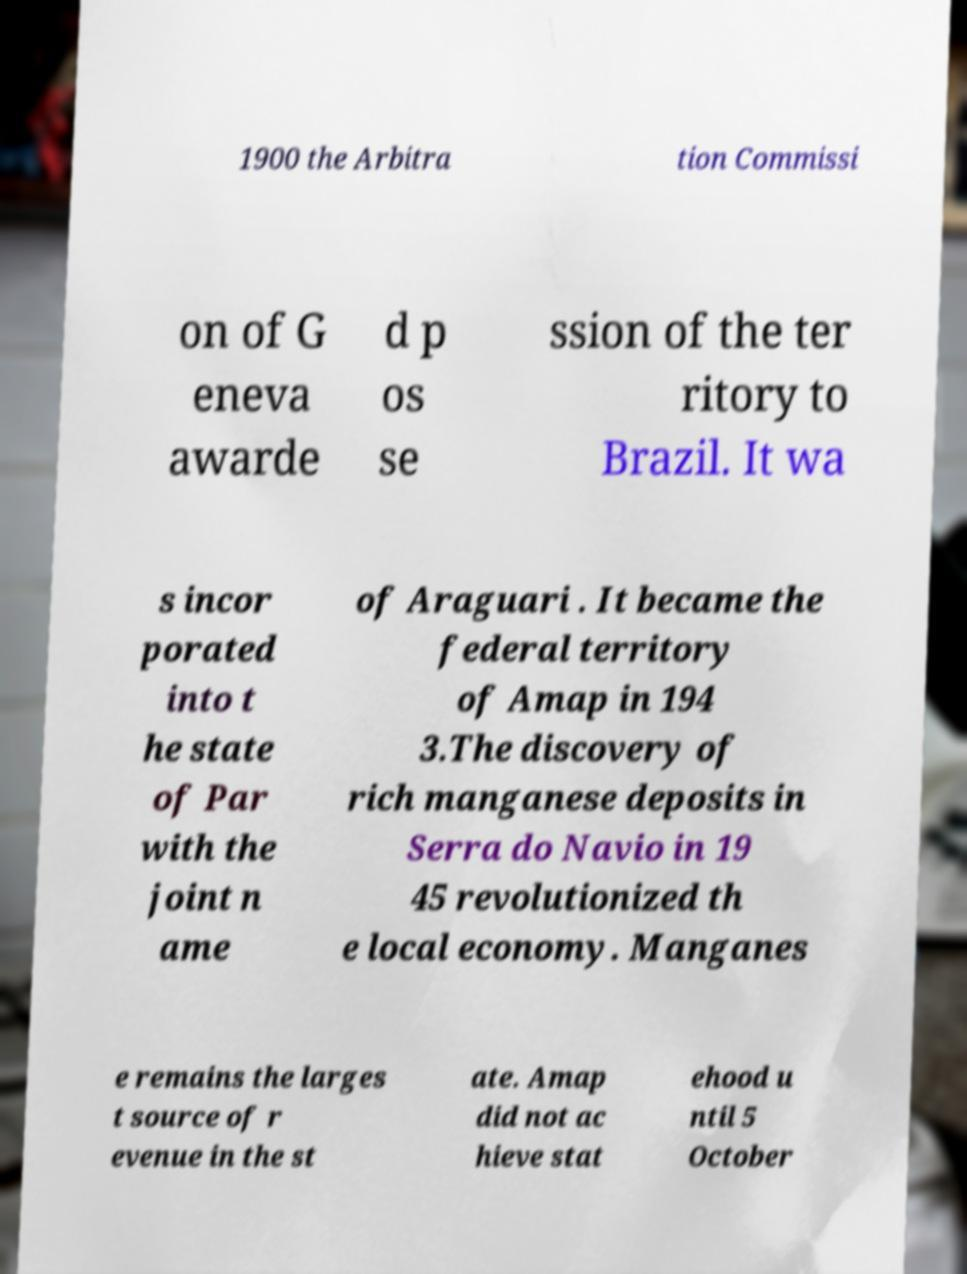I need the written content from this picture converted into text. Can you do that? 1900 the Arbitra tion Commissi on of G eneva awarde d p os se ssion of the ter ritory to Brazil. It wa s incor porated into t he state of Par with the joint n ame of Araguari . It became the federal territory of Amap in 194 3.The discovery of rich manganese deposits in Serra do Navio in 19 45 revolutionized th e local economy. Manganes e remains the larges t source of r evenue in the st ate. Amap did not ac hieve stat ehood u ntil 5 October 